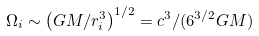<formula> <loc_0><loc_0><loc_500><loc_500>\Omega _ { i } \sim \left ( G M / r _ { i } ^ { 3 } \right ) ^ { 1 / 2 } = c ^ { 3 } / ( 6 ^ { 3 / 2 } G M )</formula> 